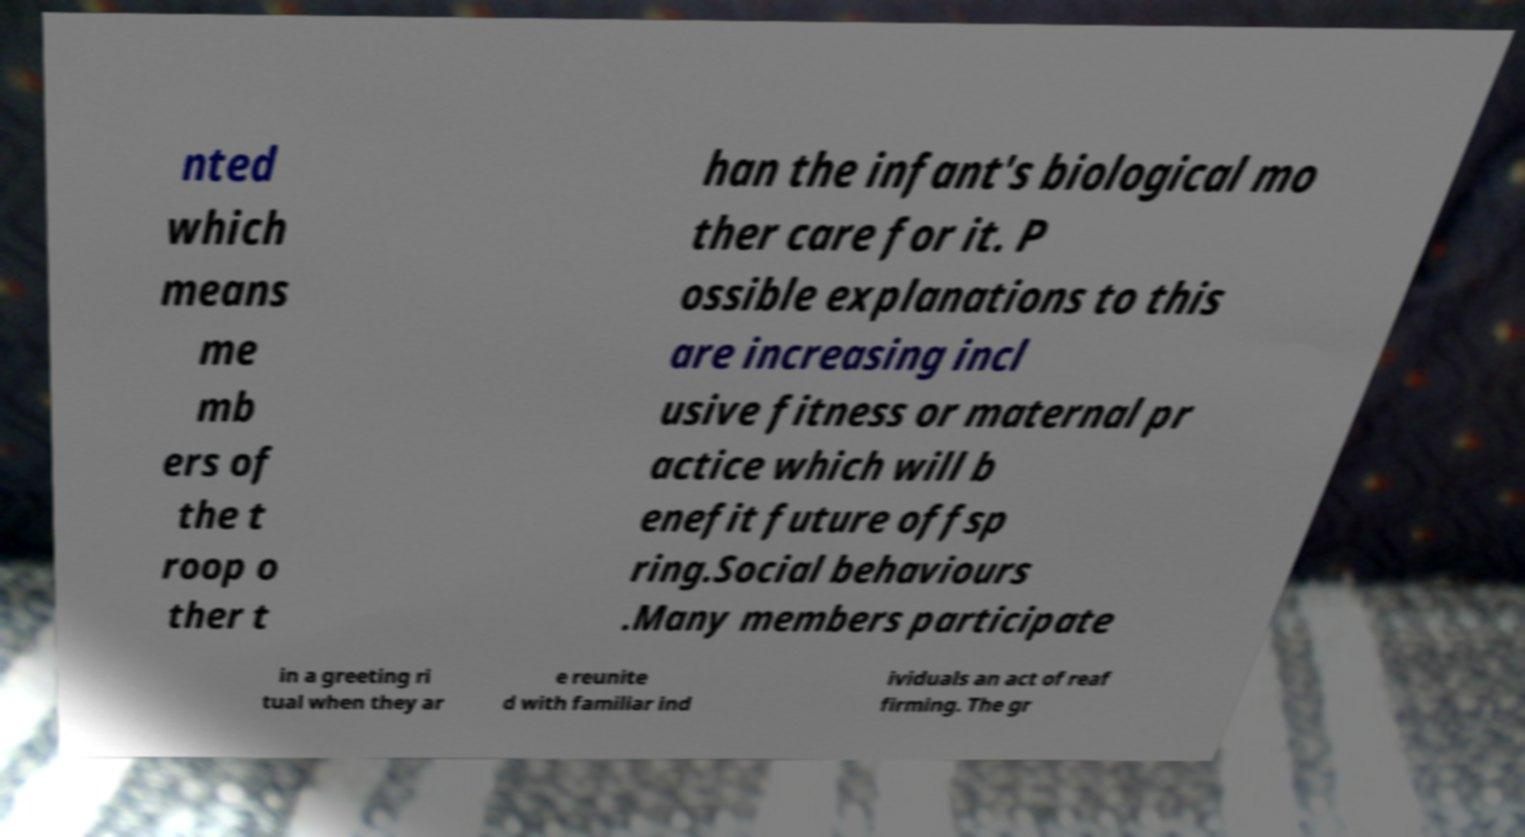Can you accurately transcribe the text from the provided image for me? nted which means me mb ers of the t roop o ther t han the infant's biological mo ther care for it. P ossible explanations to this are increasing incl usive fitness or maternal pr actice which will b enefit future offsp ring.Social behaviours .Many members participate in a greeting ri tual when they ar e reunite d with familiar ind ividuals an act of reaf firming. The gr 